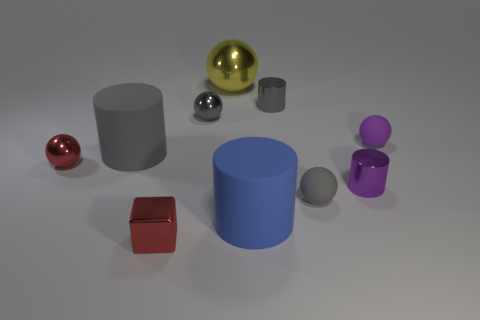Subtract all tiny gray spheres. How many spheres are left? 3 Subtract all gray blocks. How many gray balls are left? 2 Subtract all purple spheres. How many spheres are left? 4 Subtract all cylinders. How many objects are left? 6 Add 8 gray shiny objects. How many gray shiny objects exist? 10 Subtract 0 cyan cubes. How many objects are left? 10 Subtract 2 spheres. How many spheres are left? 3 Subtract all cyan spheres. Subtract all yellow blocks. How many spheres are left? 5 Subtract all blue objects. Subtract all small metal cubes. How many objects are left? 8 Add 6 gray metallic objects. How many gray metallic objects are left? 8 